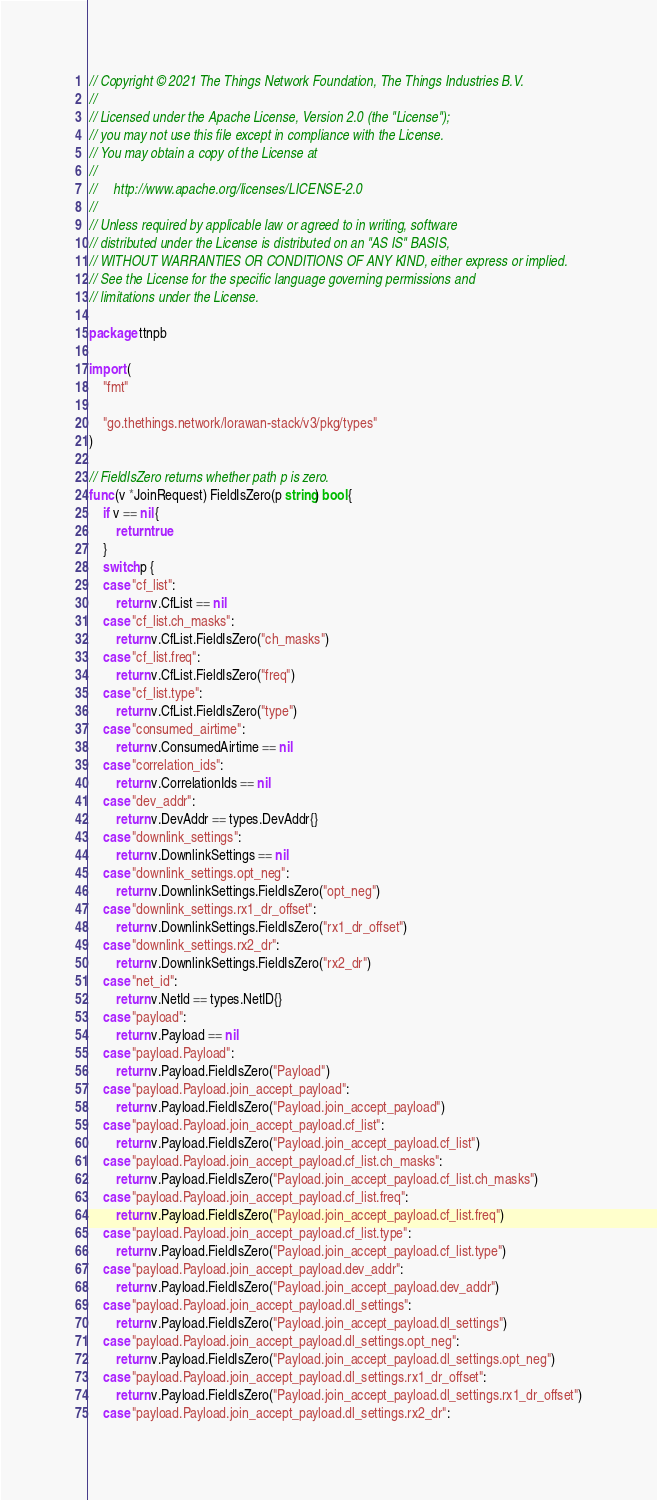<code> <loc_0><loc_0><loc_500><loc_500><_Go_>// Copyright © 2021 The Things Network Foundation, The Things Industries B.V.
//
// Licensed under the Apache License, Version 2.0 (the "License");
// you may not use this file except in compliance with the License.
// You may obtain a copy of the License at
//
//     http://www.apache.org/licenses/LICENSE-2.0
//
// Unless required by applicable law or agreed to in writing, software
// distributed under the License is distributed on an "AS IS" BASIS,
// WITHOUT WARRANTIES OR CONDITIONS OF ANY KIND, either express or implied.
// See the License for the specific language governing permissions and
// limitations under the License.

package ttnpb

import (
	"fmt"

	"go.thethings.network/lorawan-stack/v3/pkg/types"
)

// FieldIsZero returns whether path p is zero.
func (v *JoinRequest) FieldIsZero(p string) bool {
	if v == nil {
		return true
	}
	switch p {
	case "cf_list":
		return v.CfList == nil
	case "cf_list.ch_masks":
		return v.CfList.FieldIsZero("ch_masks")
	case "cf_list.freq":
		return v.CfList.FieldIsZero("freq")
	case "cf_list.type":
		return v.CfList.FieldIsZero("type")
	case "consumed_airtime":
		return v.ConsumedAirtime == nil
	case "correlation_ids":
		return v.CorrelationIds == nil
	case "dev_addr":
		return v.DevAddr == types.DevAddr{}
	case "downlink_settings":
		return v.DownlinkSettings == nil
	case "downlink_settings.opt_neg":
		return v.DownlinkSettings.FieldIsZero("opt_neg")
	case "downlink_settings.rx1_dr_offset":
		return v.DownlinkSettings.FieldIsZero("rx1_dr_offset")
	case "downlink_settings.rx2_dr":
		return v.DownlinkSettings.FieldIsZero("rx2_dr")
	case "net_id":
		return v.NetId == types.NetID{}
	case "payload":
		return v.Payload == nil
	case "payload.Payload":
		return v.Payload.FieldIsZero("Payload")
	case "payload.Payload.join_accept_payload":
		return v.Payload.FieldIsZero("Payload.join_accept_payload")
	case "payload.Payload.join_accept_payload.cf_list":
		return v.Payload.FieldIsZero("Payload.join_accept_payload.cf_list")
	case "payload.Payload.join_accept_payload.cf_list.ch_masks":
		return v.Payload.FieldIsZero("Payload.join_accept_payload.cf_list.ch_masks")
	case "payload.Payload.join_accept_payload.cf_list.freq":
		return v.Payload.FieldIsZero("Payload.join_accept_payload.cf_list.freq")
	case "payload.Payload.join_accept_payload.cf_list.type":
		return v.Payload.FieldIsZero("Payload.join_accept_payload.cf_list.type")
	case "payload.Payload.join_accept_payload.dev_addr":
		return v.Payload.FieldIsZero("Payload.join_accept_payload.dev_addr")
	case "payload.Payload.join_accept_payload.dl_settings":
		return v.Payload.FieldIsZero("Payload.join_accept_payload.dl_settings")
	case "payload.Payload.join_accept_payload.dl_settings.opt_neg":
		return v.Payload.FieldIsZero("Payload.join_accept_payload.dl_settings.opt_neg")
	case "payload.Payload.join_accept_payload.dl_settings.rx1_dr_offset":
		return v.Payload.FieldIsZero("Payload.join_accept_payload.dl_settings.rx1_dr_offset")
	case "payload.Payload.join_accept_payload.dl_settings.rx2_dr":</code> 